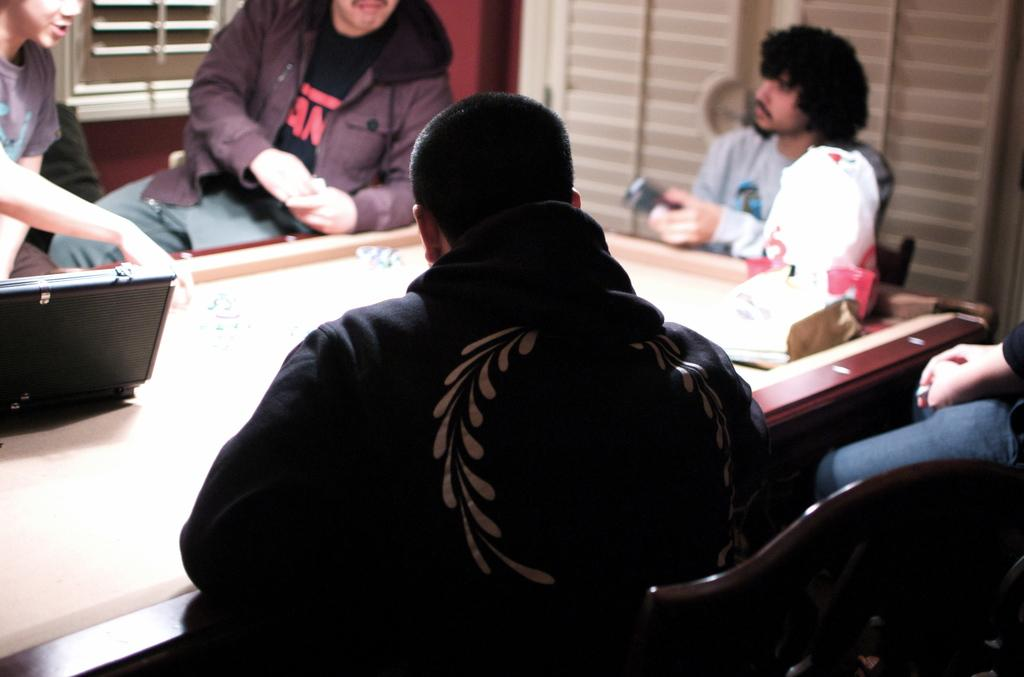How many people are present in the room? There are five people in the room. What furniture is present in the room? There is a table in the room. What electronic device is on the table? There is a laptop on the table. What other object is on the table? There is a cover bag on the table. What architectural feature is present in the room? There is a background window in the room. What type of window treatment is associated with the window? There is a curtain associated with the window. What type of farm animals can be seen in the image? There are no farm animals present in the image. 